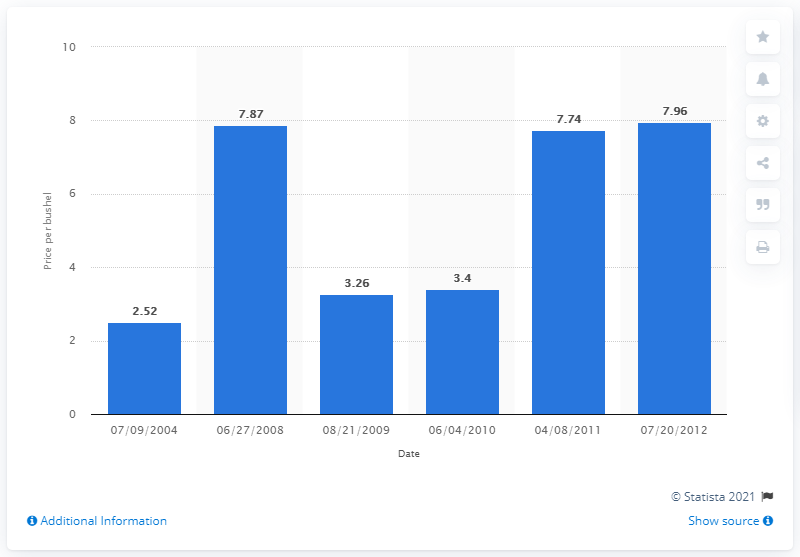Draw attention to some important aspects in this diagram. On April 8, 2011, the price of corn per bushel was 7.74 dollars. 